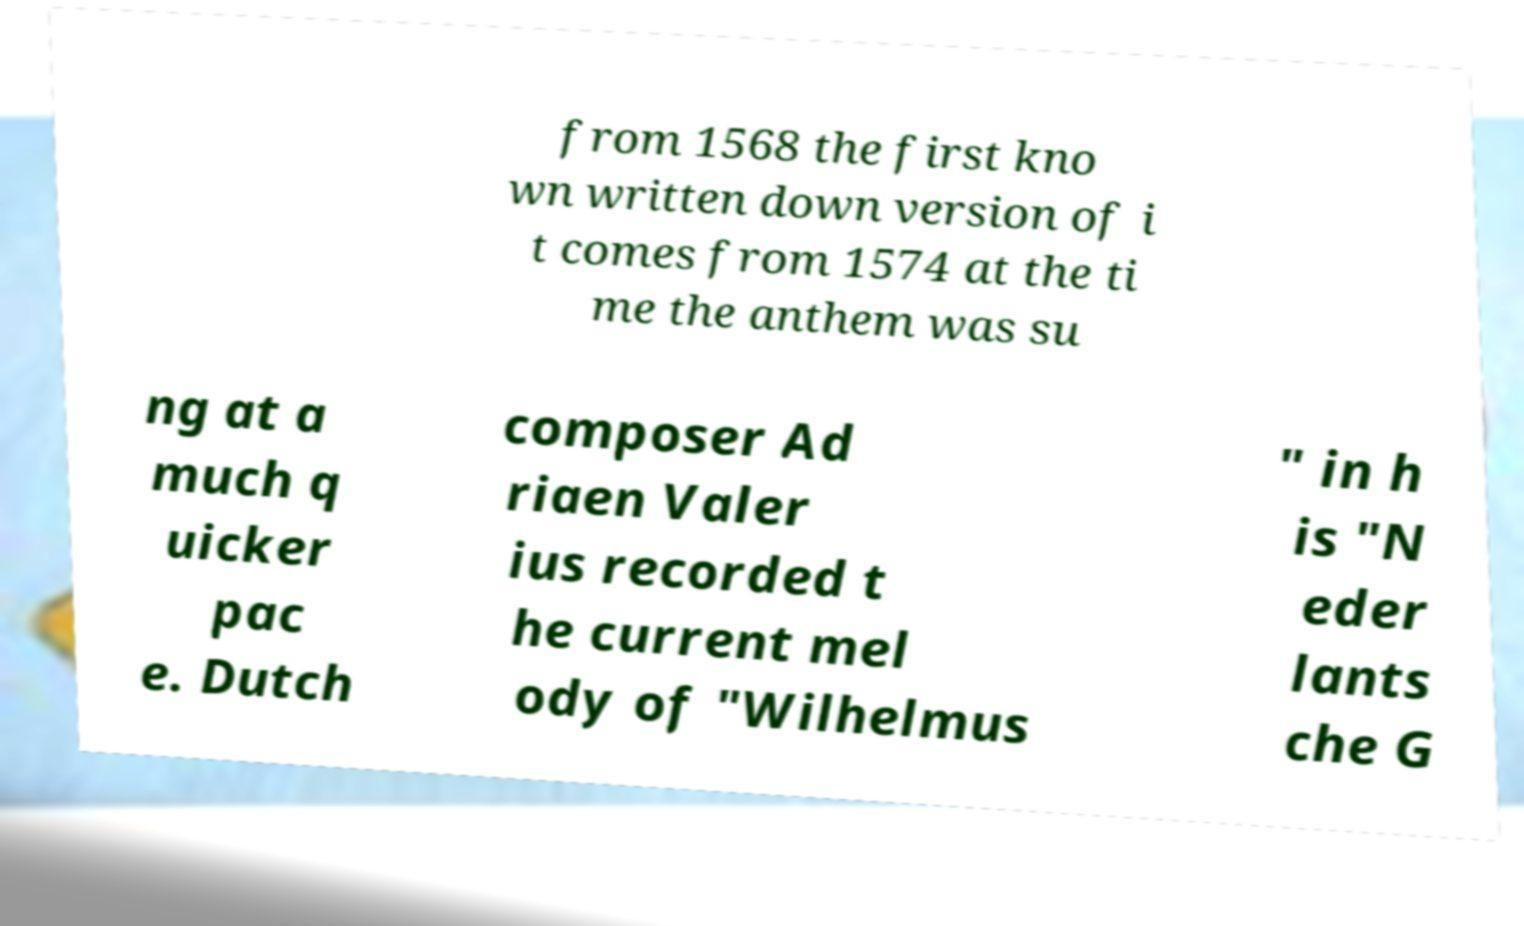What messages or text are displayed in this image? I need them in a readable, typed format. from 1568 the first kno wn written down version of i t comes from 1574 at the ti me the anthem was su ng at a much q uicker pac e. Dutch composer Ad riaen Valer ius recorded t he current mel ody of "Wilhelmus " in h is "N eder lants che G 